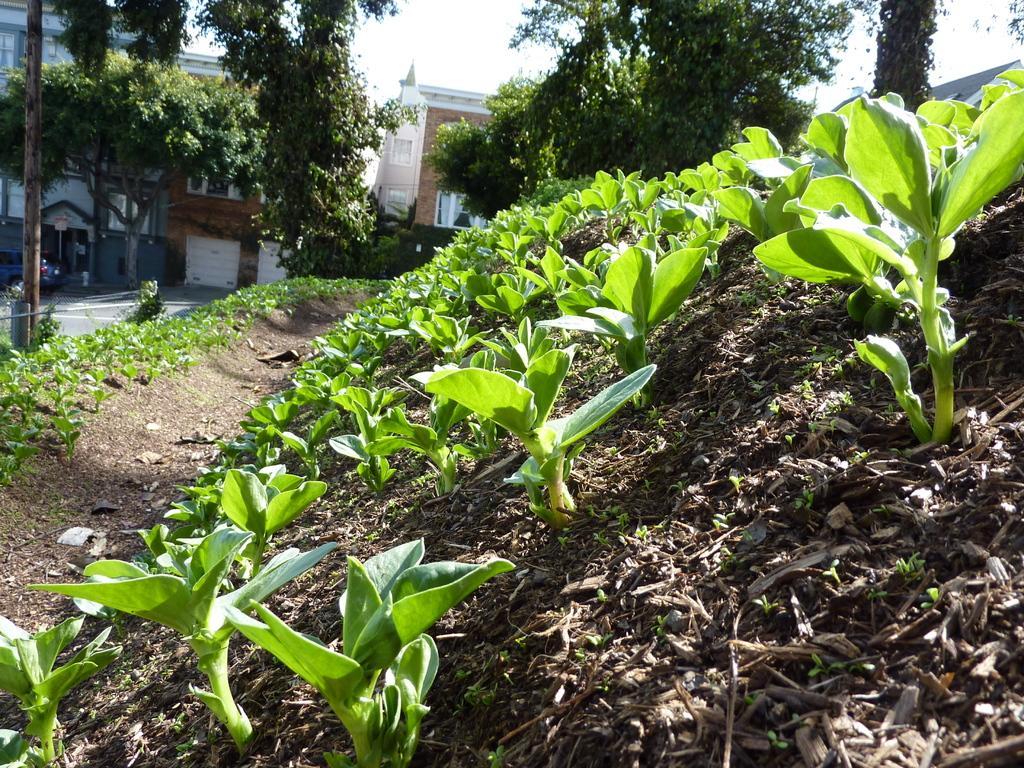Can you describe this image briefly? This picture is clicked outside. In the foreground we can see the plants and some other objects. In the background we can see the sky, buildings, trees, vehicle and a pole and some other objects. 